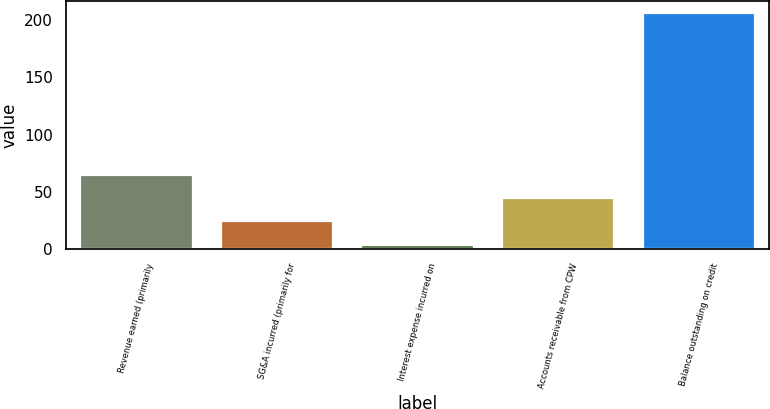<chart> <loc_0><loc_0><loc_500><loc_500><bar_chart><fcel>Revenue earned (primarily<fcel>SG&A incurred (primarily for<fcel>Interest expense incurred on<fcel>Accounts receivable from CPW<fcel>Balance outstanding on credit<nl><fcel>64.6<fcel>24.2<fcel>4<fcel>44.4<fcel>206<nl></chart> 